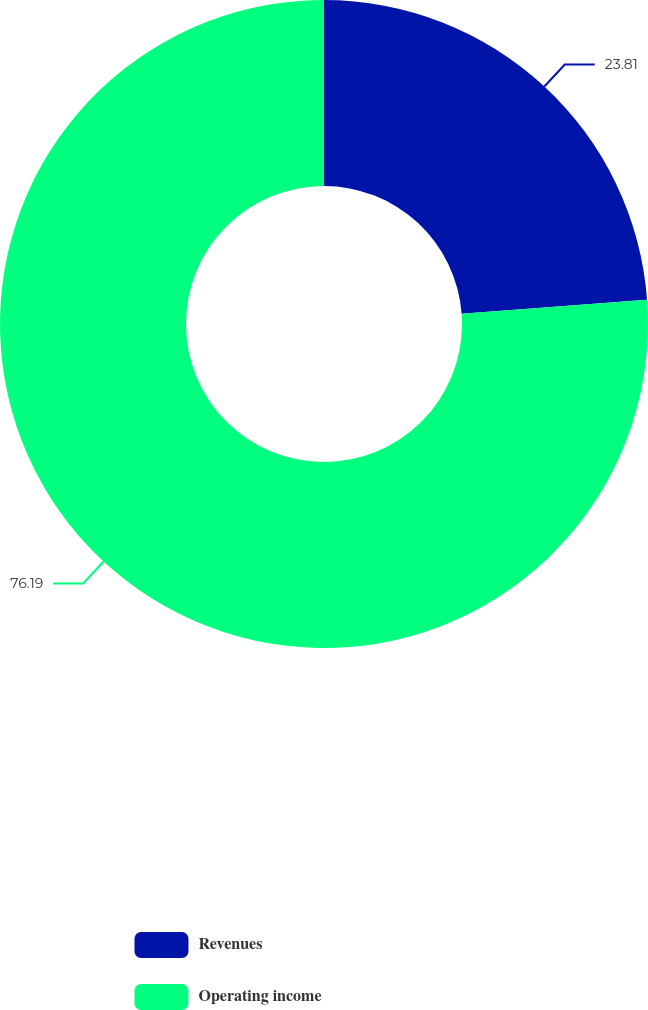<chart> <loc_0><loc_0><loc_500><loc_500><pie_chart><fcel>Revenues<fcel>Operating income<nl><fcel>23.81%<fcel>76.19%<nl></chart> 